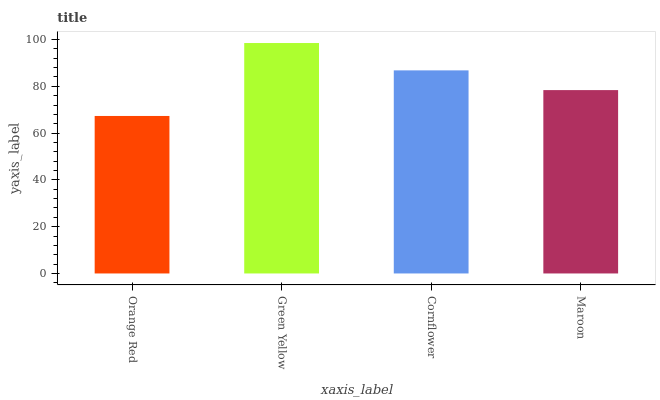Is Cornflower the minimum?
Answer yes or no. No. Is Cornflower the maximum?
Answer yes or no. No. Is Green Yellow greater than Cornflower?
Answer yes or no. Yes. Is Cornflower less than Green Yellow?
Answer yes or no. Yes. Is Cornflower greater than Green Yellow?
Answer yes or no. No. Is Green Yellow less than Cornflower?
Answer yes or no. No. Is Cornflower the high median?
Answer yes or no. Yes. Is Maroon the low median?
Answer yes or no. Yes. Is Maroon the high median?
Answer yes or no. No. Is Cornflower the low median?
Answer yes or no. No. 